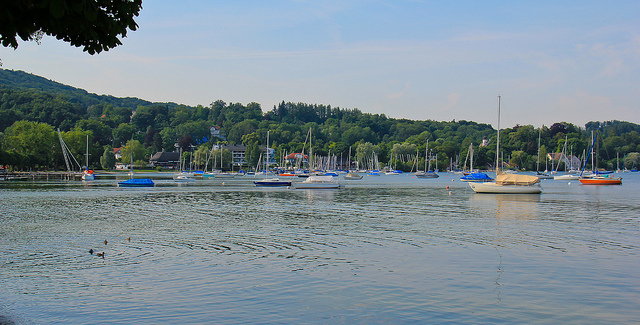<image>What marina are the boats at? I don't know which marina the boats are at. It's not possible to tell from the image. What marina are the boats at? I am not sure what marina the boats are at. It could be "boat marina", "monroe's marina", "sailboat" or "that one". 